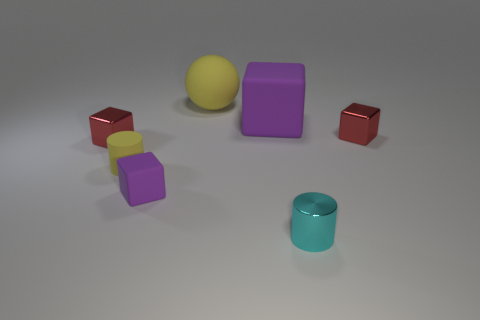Subtract all large purple matte cubes. How many cubes are left? 3 Subtract all purple balls. How many red cubes are left? 2 Subtract 2 cylinders. How many cylinders are left? 0 Add 2 small purple objects. How many objects exist? 9 Subtract all purple cubes. How many cubes are left? 2 Subtract all blocks. How many objects are left? 3 Add 3 big purple rubber things. How many big purple rubber things exist? 4 Subtract 0 cyan balls. How many objects are left? 7 Subtract all yellow blocks. Subtract all gray spheres. How many blocks are left? 4 Subtract all small yellow rubber cylinders. Subtract all metallic things. How many objects are left? 3 